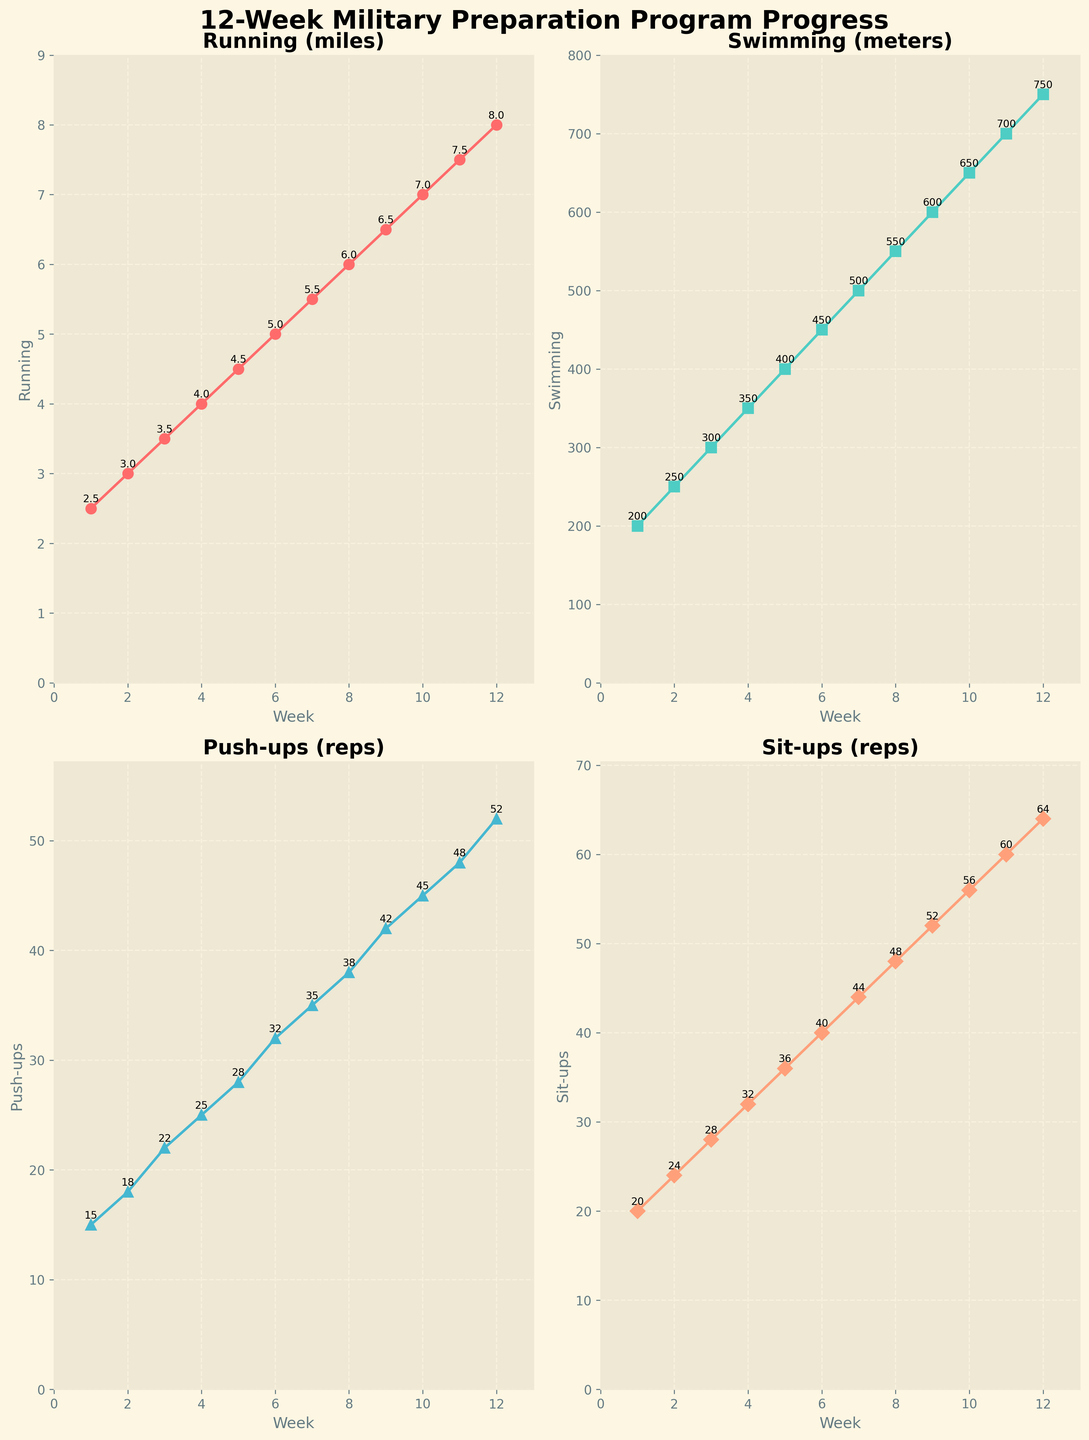What is the maximum distance covered in running over the 12 weeks? The maximum distance covered in running can be found by locating the highest data point in the "Running (miles)" subplot. According to the figure, the highest value for running is 8.0 miles observed in week 12.
Answer: 8.0 miles How many weeks did it take for the number of push-ups to reach at least 30? Look at the "Push-ups (reps)" subplot and identify the week where the number of push-ups first reaches or exceeds 30. This happens in week 6, where 32 push-ups are recorded.
Answer: 6 weeks What is the total increase in running distance from week 1 to week 12? Calculate the difference between the running distance in week 1 and week 12 by subtracting the week 1 value from the week 12 value. Week 12: 8.0 miles, Week 1: 2.5 miles, Total increase: 8.0 - 2.5 = 5.5 miles.
Answer: 5.5 miles Which exercise shows the most consistent increase week over week? To find the most consistent increase, visually inspect the slopes of the lines in all subplots. The most linear or steady upward trend defines the most consistent increase. "Running (miles)" shows a consistent and steady increase every week by an equal increment of 0.5 miles.
Answer: Running (miles) By how much did the number of sit-ups increase from week 7 to week 10? Look at the "Sit-ups (reps)" subplot and note the values at weeks 7 and 10. Week 7: 44 sit-ups, Week 10: 56 sit-ups. Calculate the difference: 56 - 44 = 12 sit-ups.
Answer: 12 sit-ups On which week was the highest number of swimming meters achieved? Identify the highest data point in the "Swimming (meters)" subplot. The highest number of swimming meters is 750, which was achieved in week 12.
Answer: Week 12 Compare the improvement in push-ups to sit-ups from week 5 to 12. Which had a greater improvement? Note the values for push-ups and sit-ups in weeks 5 and 12 and calculate the improvement for each. Push-ups Week 5: 28, Week 12: 52, Improvement: 52 - 28 = 24 reps. Sit-ups Week 5: 36, Week 12: 64, Improvement: 64 - 36 = 28 reps. Sit-ups had a greater improvement than push-ups.
Answer: Sit-ups What was the weekly increase rate of swimming meters on average over 12 weeks? Divide the total increase in swimming meters from week 1 to week 12 by the number of weeks. Initial value: 200 meters, Final value: 750 meters, Total increase: 750 - 200 = 550 meters over 12 weeks. Average weekly increase: 550 / 12 ≈ 45.83 meters.
Answer: 45.83 meters Which week showed the first time the running distance was at least 6 miles? Identify from the "Running (miles)" subplot the first week where the running distance was 6 miles or more. It first reaches 6 miles in week 8.
Answer: Week 8 